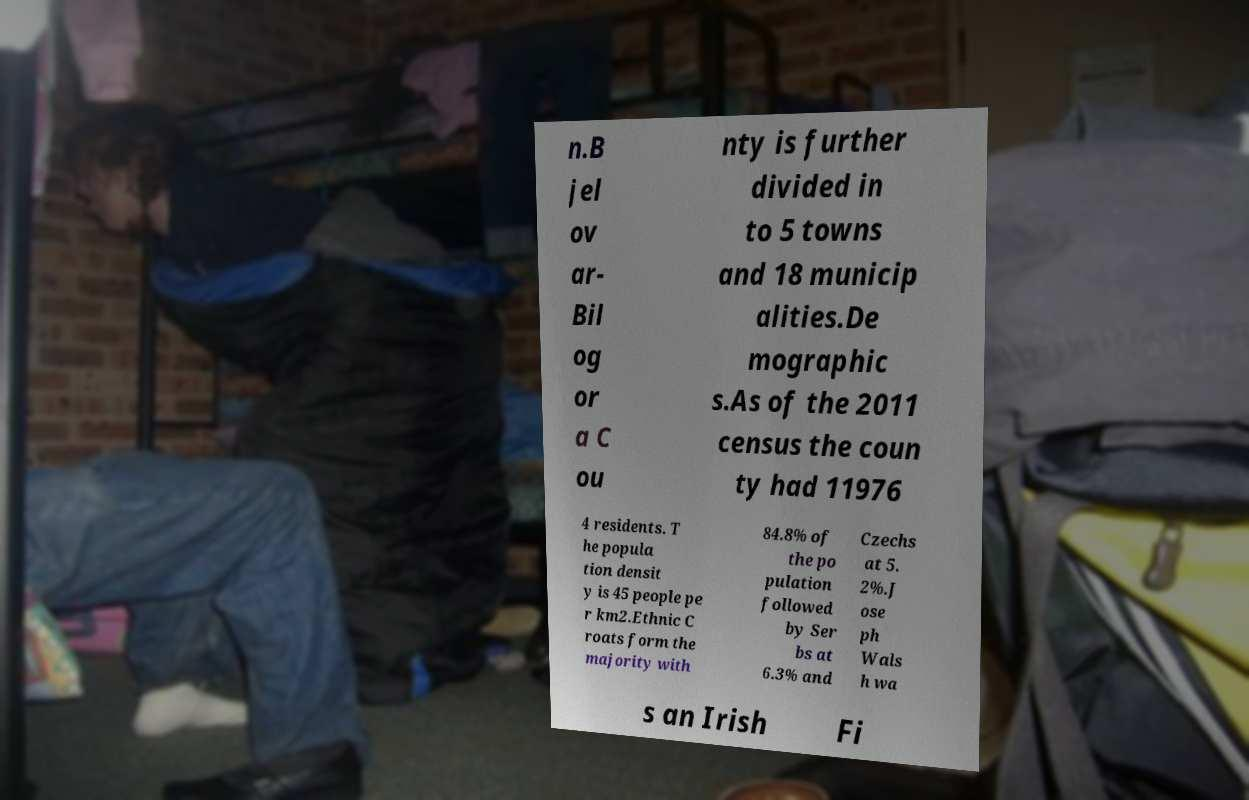Can you read and provide the text displayed in the image?This photo seems to have some interesting text. Can you extract and type it out for me? n.B jel ov ar- Bil og or a C ou nty is further divided in to 5 towns and 18 municip alities.De mographic s.As of the 2011 census the coun ty had 11976 4 residents. T he popula tion densit y is 45 people pe r km2.Ethnic C roats form the majority with 84.8% of the po pulation followed by Ser bs at 6.3% and Czechs at 5. 2%.J ose ph Wals h wa s an Irish Fi 